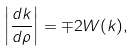Convert formula to latex. <formula><loc_0><loc_0><loc_500><loc_500>\left | \frac { d k } { d \rho } \right | = \mp 2 W ( k ) ,</formula> 